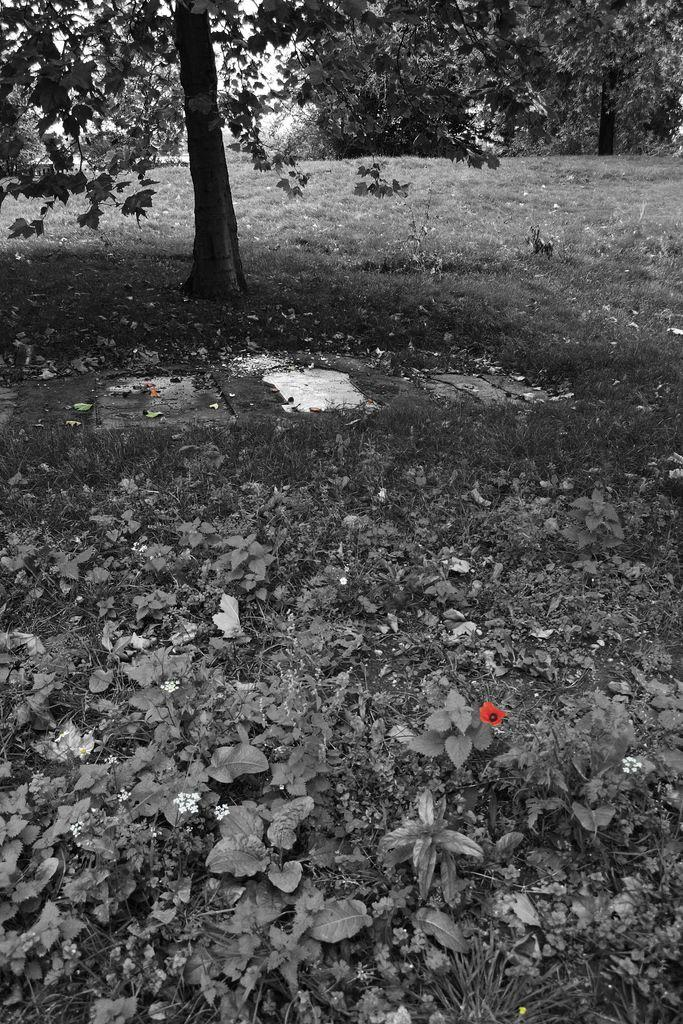What type of vegetation can be seen on the ground in the image? There are dried leaves and grass on the ground in the image. What can be seen in the background of the image? There are trees in the background of the image. Where is the lettuce growing in the image? There is no lettuce present in the image. Can you see a mountain in the background of the image? There is no mountain visible in the image; only trees are present in the background. 